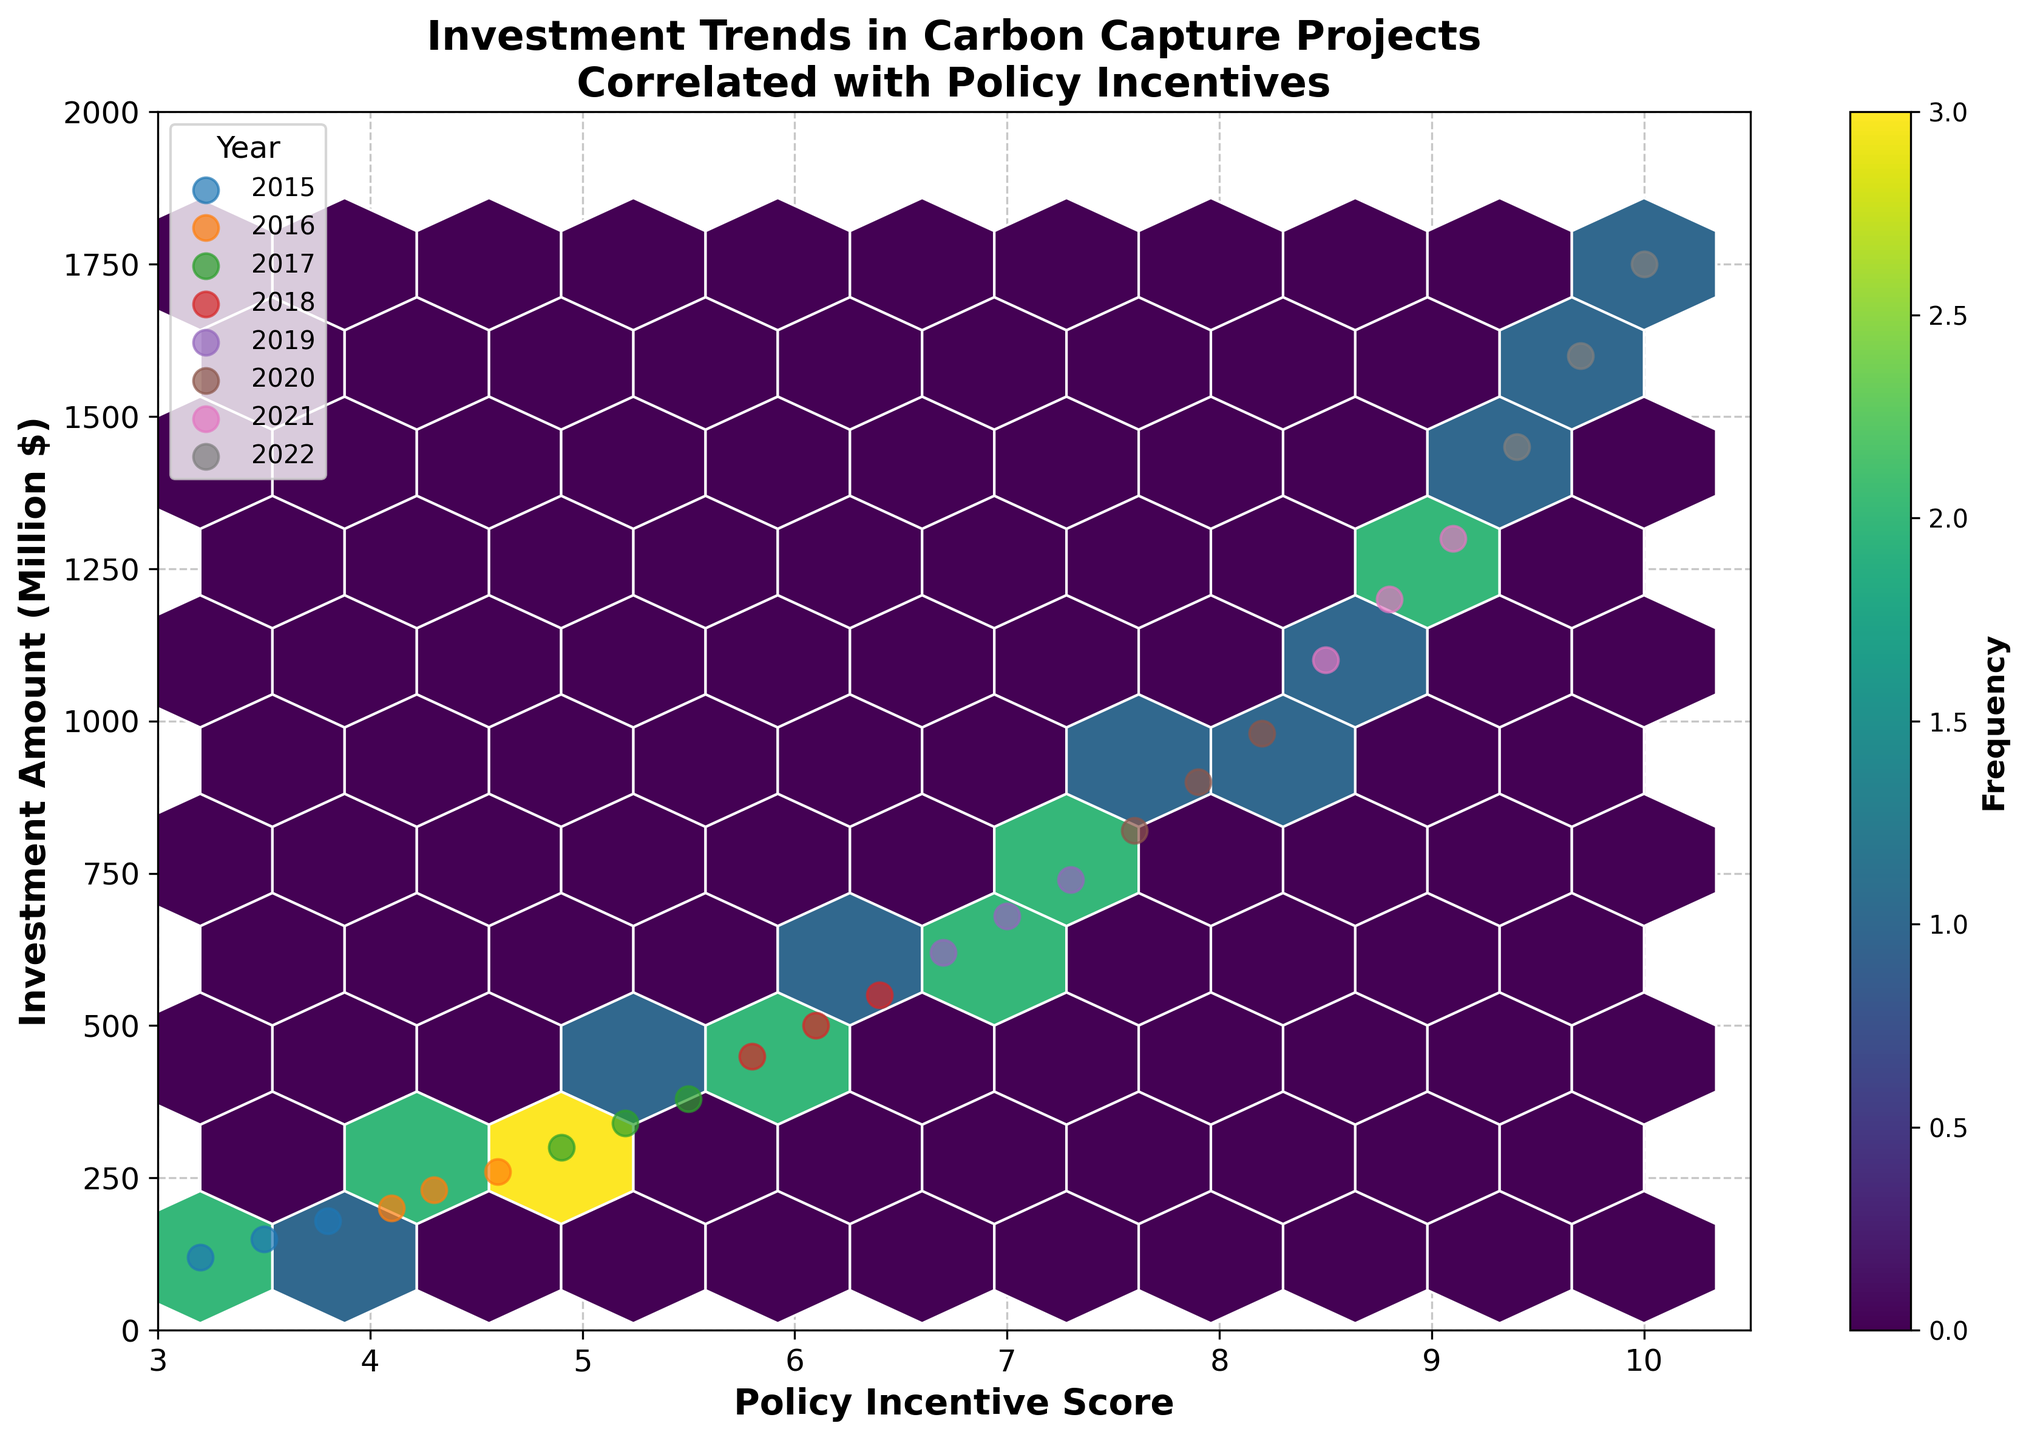What's the title of the plot? The title is displayed at the top of the plot.
Answer: Investment Trends in Carbon Capture Projects Correlated with Policy Incentives What are the labels for the X and Y axes? The labels for the axes are written along the respective axes. The X-axis label is 'Policy Incentive Score' and the Y-axis label is 'Investment Amount (Million $)'.
Answer: Policy Incentive Score and Investment Amount (Million $) How many years are represented in the plot, and what are they? The unique points labeled in the legend show the different years.
Answer: Eight years: 2015, 2016, 2017, 2018, 2019, 2020, 2021, 2022 Which year shows the highest investment amount, and what is that amount? By examining the scatter points on the plot, particularly the highest point on the Y-axis for each year, we can see which year has the largest value and read off that value.
Answer: 2022, $1750 Million What's the overall trend in investment amounts as the policy incentive score increases? Observing the general direction of the scatter points and hexbin density as we move from left to right on the X-axis, we can see if the investments are generally increasing or decreasing.
Answer: Increasing Which policy incentive score range has the highest frequency of investments? By looking at the density of the hexagons on the plot (most frequent) as indicated by the color, we can determine the range with the highest frequency.
Answer: Between 3 and 6 On average, how does the investment amount change from 2015 to 2019 and then from 2019 to 2022? To find this, calculate the mean investment for 2015-2019 and then 2019-2022, and compare the two averages. From the plot, you can spot the general increase trends.
Answer: Increased How does the investment in 2017 compare to that in 2021? Locate the points for 2017 and 2021 on the plot. Compare the values on the Y-axis. 2021 investments should be higher based on visible data points.
Answer: 2021 investments are higher What pattern do you observe in the hexbin plot relative to policy incentive scores and investment amounts? By looking at the pattern of the hexagons, we can describe whether there's clustering at certain points which would indicate higher frequency.
Answer: Clusters increase with higher policy incentive scores and investment amounts Are there any outliers in the data? If so, in what year? Outliers are represented by scatter points that are significantly distant from clusters of other points.
Answer: 2022 (the $1750 Million point) 